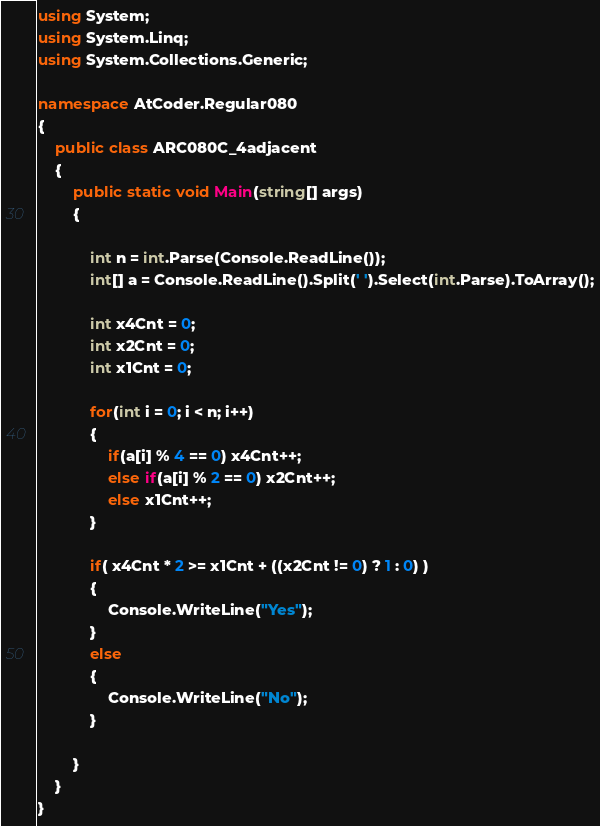<code> <loc_0><loc_0><loc_500><loc_500><_C#_>using System;
using System.Linq;
using System.Collections.Generic;

namespace AtCoder.Regular080
{
    public class ARC080C_4adjacent
    {
        public static void Main(string[] args)
        {
            
            int n = int.Parse(Console.ReadLine());
            int[] a = Console.ReadLine().Split(' ').Select(int.Parse).ToArray();

            int x4Cnt = 0;
            int x2Cnt = 0;
            int x1Cnt = 0;

            for(int i = 0; i < n; i++)
            {
                if(a[i] % 4 == 0) x4Cnt++;
                else if(a[i] % 2 == 0) x2Cnt++;
                else x1Cnt++;
            }

            if( x4Cnt * 2 >= x1Cnt + ((x2Cnt != 0) ? 1 : 0) )
            {
                Console.WriteLine("Yes");
            }
            else
            {
                Console.WriteLine("No");
            }
            
        }
    }
}</code> 